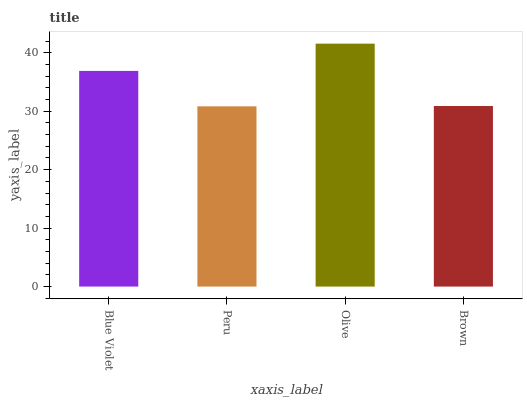Is Peru the minimum?
Answer yes or no. Yes. Is Olive the maximum?
Answer yes or no. Yes. Is Olive the minimum?
Answer yes or no. No. Is Peru the maximum?
Answer yes or no. No. Is Olive greater than Peru?
Answer yes or no. Yes. Is Peru less than Olive?
Answer yes or no. Yes. Is Peru greater than Olive?
Answer yes or no. No. Is Olive less than Peru?
Answer yes or no. No. Is Blue Violet the high median?
Answer yes or no. Yes. Is Brown the low median?
Answer yes or no. Yes. Is Brown the high median?
Answer yes or no. No. Is Peru the low median?
Answer yes or no. No. 